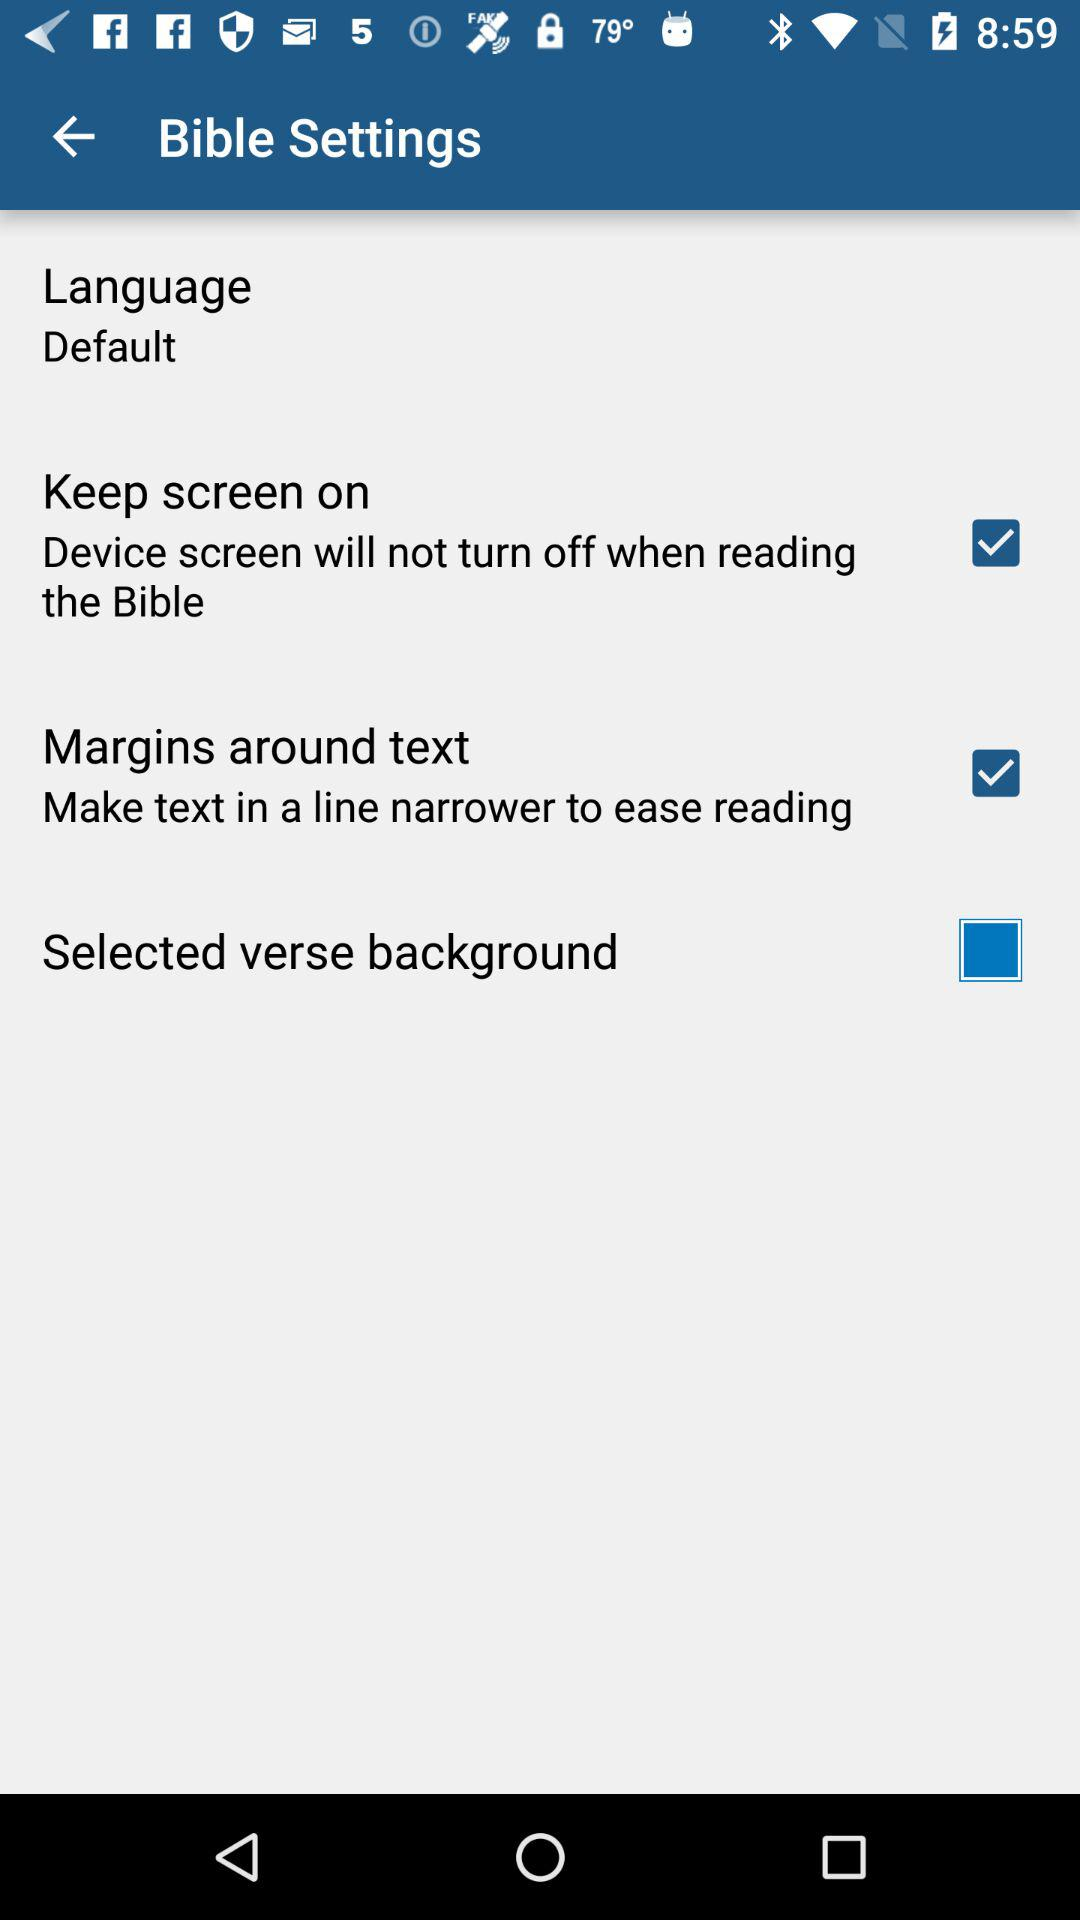What is the status of selected verse background?
When the provided information is insufficient, respond with <no answer>. <no answer> 